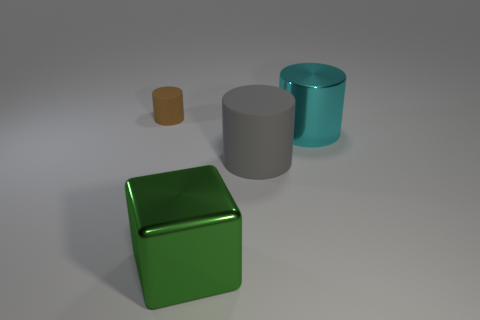Add 1 big cyan rubber blocks. How many objects exist? 5 Subtract all cylinders. How many objects are left? 1 Subtract 0 green cylinders. How many objects are left? 4 Subtract all tiny cylinders. Subtract all tiny brown rubber things. How many objects are left? 2 Add 1 gray cylinders. How many gray cylinders are left? 2 Add 3 big cyan cylinders. How many big cyan cylinders exist? 4 